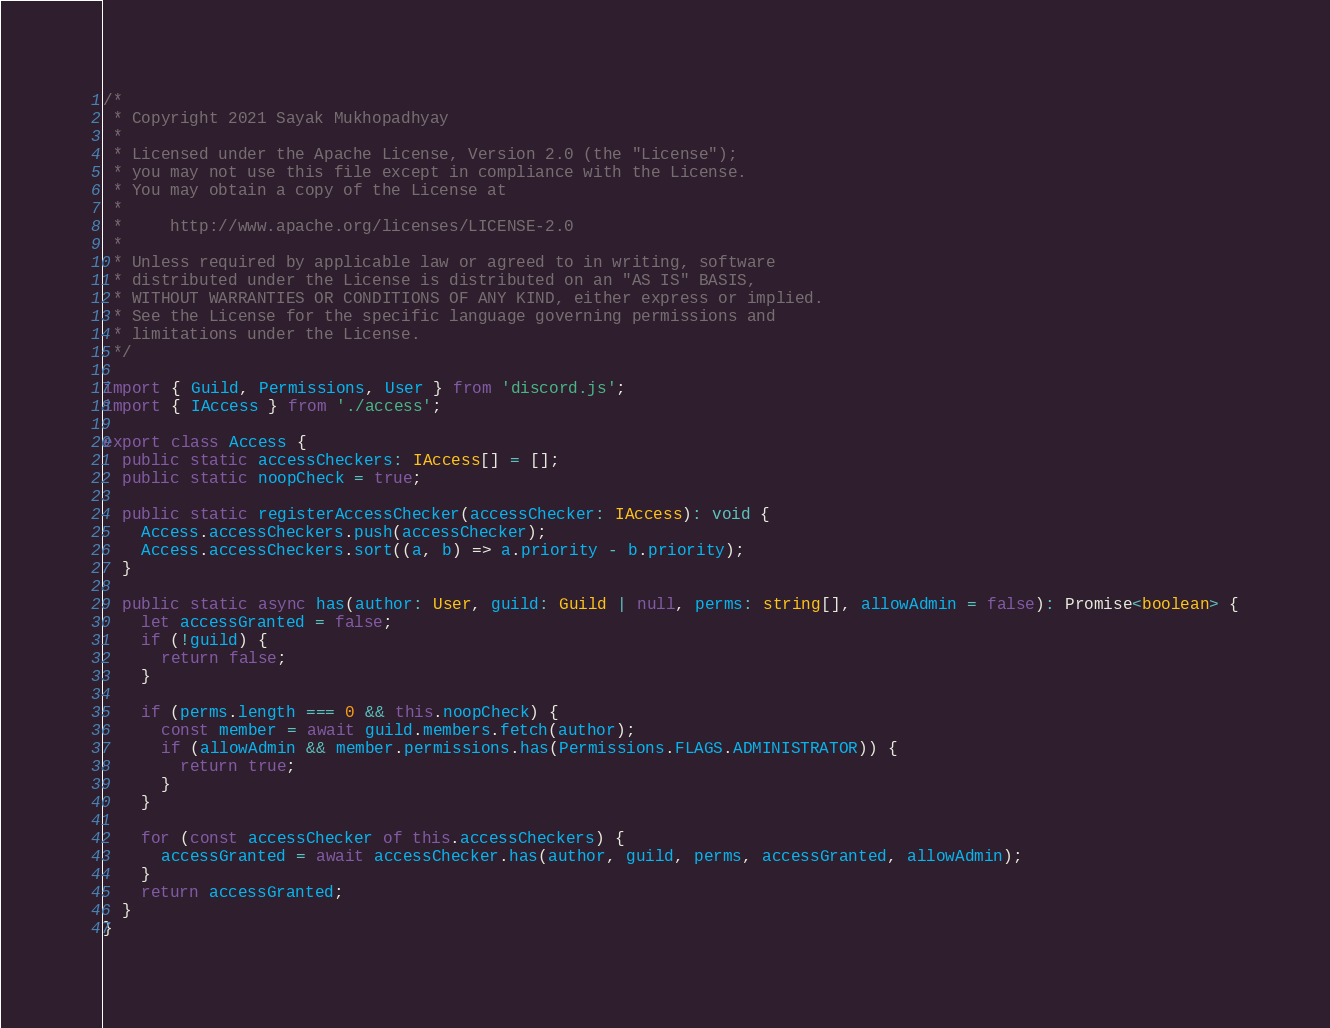Convert code to text. <code><loc_0><loc_0><loc_500><loc_500><_TypeScript_>/*
 * Copyright 2021 Sayak Mukhopadhyay
 *
 * Licensed under the Apache License, Version 2.0 (the "License");
 * you may not use this file except in compliance with the License.
 * You may obtain a copy of the License at
 *
 *     http://www.apache.org/licenses/LICENSE-2.0
 *
 * Unless required by applicable law or agreed to in writing, software
 * distributed under the License is distributed on an "AS IS" BASIS,
 * WITHOUT WARRANTIES OR CONDITIONS OF ANY KIND, either express or implied.
 * See the License for the specific language governing permissions and
 * limitations under the License.
 */

import { Guild, Permissions, User } from 'discord.js';
import { IAccess } from './access';

export class Access {
  public static accessCheckers: IAccess[] = [];
  public static noopCheck = true;

  public static registerAccessChecker(accessChecker: IAccess): void {
    Access.accessCheckers.push(accessChecker);
    Access.accessCheckers.sort((a, b) => a.priority - b.priority);
  }

  public static async has(author: User, guild: Guild | null, perms: string[], allowAdmin = false): Promise<boolean> {
    let accessGranted = false;
    if (!guild) {
      return false;
    }

    if (perms.length === 0 && this.noopCheck) {
      const member = await guild.members.fetch(author);
      if (allowAdmin && member.permissions.has(Permissions.FLAGS.ADMINISTRATOR)) {
        return true;
      }
    }

    for (const accessChecker of this.accessCheckers) {
      accessGranted = await accessChecker.has(author, guild, perms, accessGranted, allowAdmin);
    }
    return accessGranted;
  }
}
</code> 